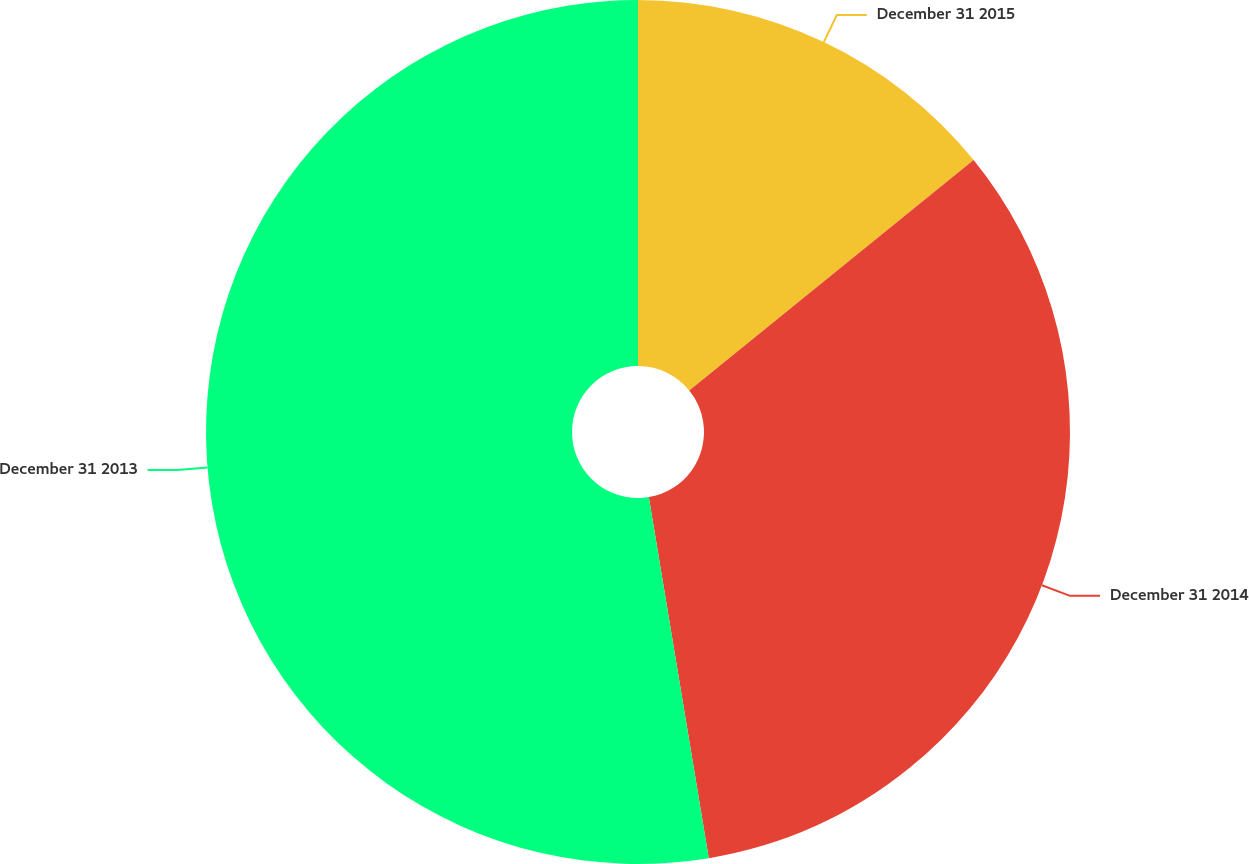<chart> <loc_0><loc_0><loc_500><loc_500><pie_chart><fcel>December 31 2015<fcel>December 31 2014<fcel>December 31 2013<nl><fcel>14.16%<fcel>33.22%<fcel>52.62%<nl></chart> 